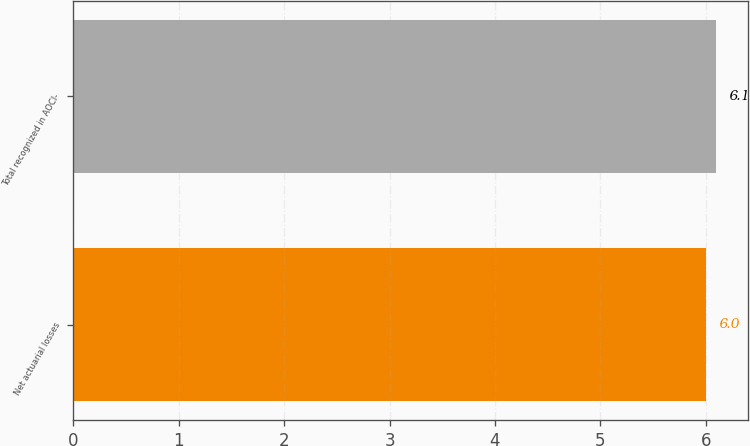<chart> <loc_0><loc_0><loc_500><loc_500><bar_chart><fcel>Net actuarial losses<fcel>Total recognized in AOCI-<nl><fcel>6<fcel>6.1<nl></chart> 